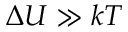<formula> <loc_0><loc_0><loc_500><loc_500>\Delta U \gg k T</formula> 